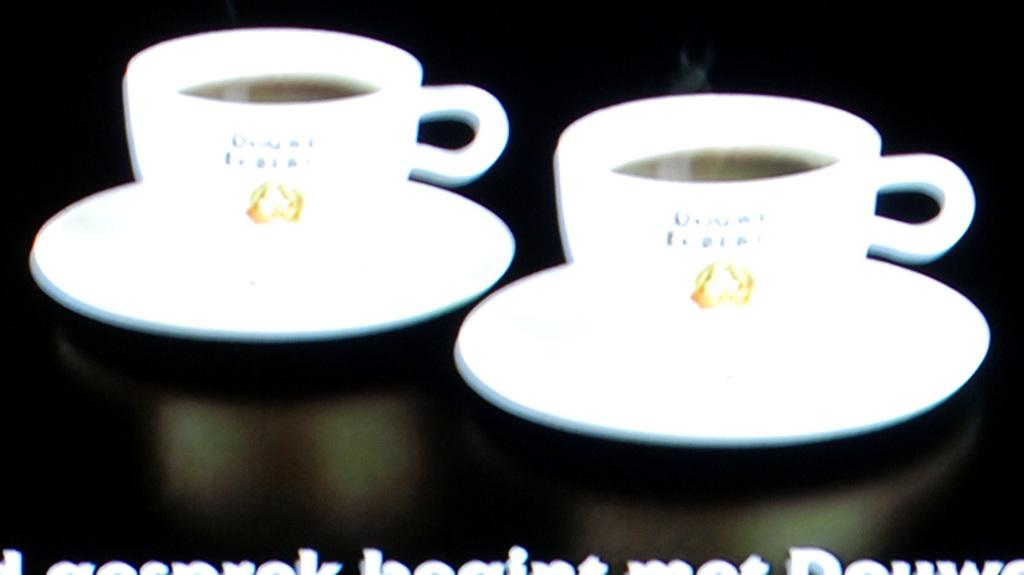What type of objects are present in the image? There are cups and saucers in the image. What is inside the cups? There is a drink in the cups. Is there any text visible on the cups or saucers? Yes, there is text written on the cups or saucers. What type of hat is the unit wearing in the image? There is no unit or hat present in the image. Is there a band performing in the image? There is no band or performance depicted in the image. 